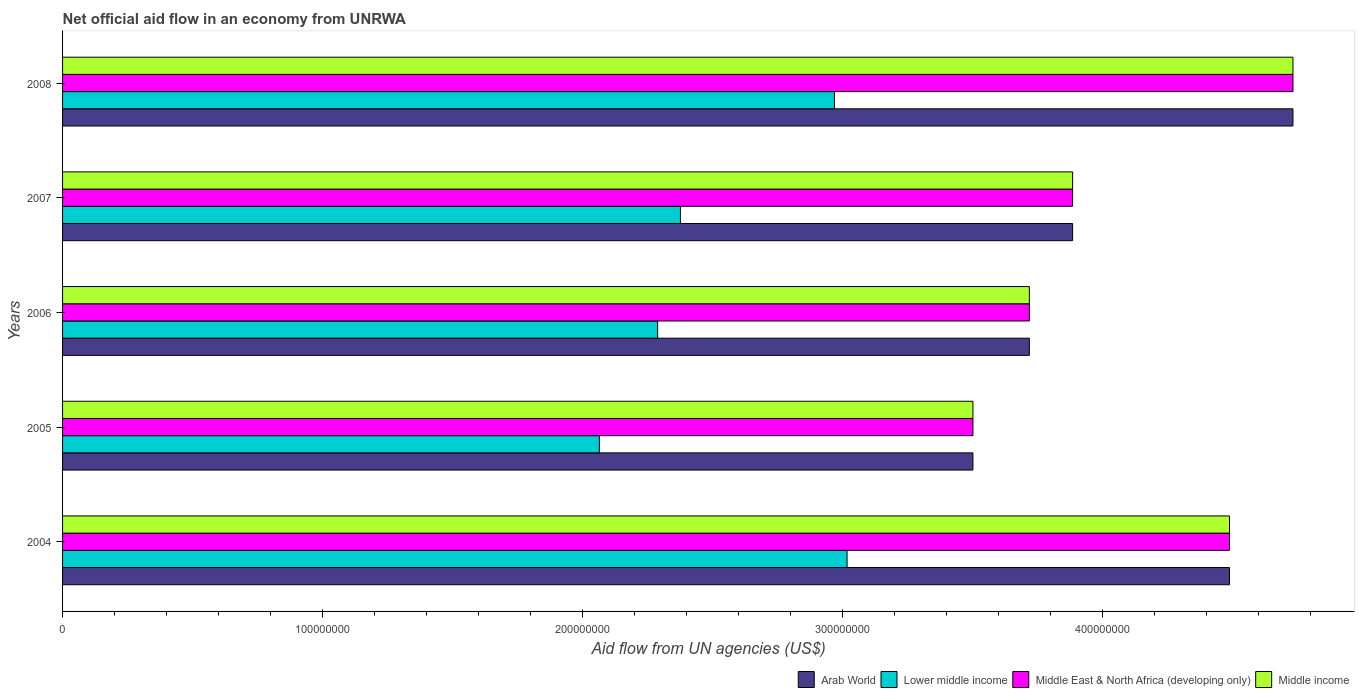How many groups of bars are there?
Your answer should be compact. 5. Are the number of bars on each tick of the Y-axis equal?
Ensure brevity in your answer.  Yes. How many bars are there on the 4th tick from the bottom?
Offer a very short reply. 4. What is the label of the 3rd group of bars from the top?
Give a very brief answer. 2006. What is the net official aid flow in Middle income in 2005?
Keep it short and to the point. 3.50e+08. Across all years, what is the maximum net official aid flow in Arab World?
Offer a terse response. 4.73e+08. Across all years, what is the minimum net official aid flow in Lower middle income?
Keep it short and to the point. 2.06e+08. In which year was the net official aid flow in Lower middle income maximum?
Ensure brevity in your answer.  2004. What is the total net official aid flow in Middle East & North Africa (developing only) in the graph?
Your response must be concise. 2.03e+09. What is the difference between the net official aid flow in Arab World in 2005 and that in 2006?
Keep it short and to the point. -2.17e+07. What is the difference between the net official aid flow in Arab World in 2008 and the net official aid flow in Middle East & North Africa (developing only) in 2007?
Your answer should be very brief. 8.48e+07. What is the average net official aid flow in Middle East & North Africa (developing only) per year?
Keep it short and to the point. 4.06e+08. In the year 2006, what is the difference between the net official aid flow in Middle income and net official aid flow in Lower middle income?
Your answer should be very brief. 1.43e+08. What is the ratio of the net official aid flow in Lower middle income in 2005 to that in 2008?
Keep it short and to the point. 0.7. Is the net official aid flow in Middle income in 2004 less than that in 2007?
Your response must be concise. No. Is the difference between the net official aid flow in Middle income in 2004 and 2006 greater than the difference between the net official aid flow in Lower middle income in 2004 and 2006?
Make the answer very short. Yes. What is the difference between the highest and the second highest net official aid flow in Middle income?
Provide a succinct answer. 2.44e+07. What is the difference between the highest and the lowest net official aid flow in Middle East & North Africa (developing only)?
Make the answer very short. 1.23e+08. In how many years, is the net official aid flow in Lower middle income greater than the average net official aid flow in Lower middle income taken over all years?
Ensure brevity in your answer.  2. Is it the case that in every year, the sum of the net official aid flow in Lower middle income and net official aid flow in Arab World is greater than the sum of net official aid flow in Middle East & North Africa (developing only) and net official aid flow in Middle income?
Provide a short and direct response. Yes. What does the 1st bar from the bottom in 2007 represents?
Your answer should be very brief. Arab World. Is it the case that in every year, the sum of the net official aid flow in Arab World and net official aid flow in Middle income is greater than the net official aid flow in Lower middle income?
Offer a very short reply. Yes. How many bars are there?
Your answer should be compact. 20. Are all the bars in the graph horizontal?
Your response must be concise. Yes. How many years are there in the graph?
Provide a succinct answer. 5. What is the difference between two consecutive major ticks on the X-axis?
Your answer should be very brief. 1.00e+08. Does the graph contain grids?
Offer a terse response. No. Where does the legend appear in the graph?
Your answer should be very brief. Bottom right. How are the legend labels stacked?
Your answer should be compact. Horizontal. What is the title of the graph?
Ensure brevity in your answer.  Net official aid flow in an economy from UNRWA. Does "Rwanda" appear as one of the legend labels in the graph?
Ensure brevity in your answer.  No. What is the label or title of the X-axis?
Your response must be concise. Aid flow from UN agencies (US$). What is the Aid flow from UN agencies (US$) in Arab World in 2004?
Provide a short and direct response. 4.49e+08. What is the Aid flow from UN agencies (US$) of Lower middle income in 2004?
Offer a very short reply. 3.02e+08. What is the Aid flow from UN agencies (US$) of Middle East & North Africa (developing only) in 2004?
Give a very brief answer. 4.49e+08. What is the Aid flow from UN agencies (US$) in Middle income in 2004?
Provide a short and direct response. 4.49e+08. What is the Aid flow from UN agencies (US$) of Arab World in 2005?
Keep it short and to the point. 3.50e+08. What is the Aid flow from UN agencies (US$) of Lower middle income in 2005?
Your answer should be very brief. 2.06e+08. What is the Aid flow from UN agencies (US$) in Middle East & North Africa (developing only) in 2005?
Provide a short and direct response. 3.50e+08. What is the Aid flow from UN agencies (US$) in Middle income in 2005?
Provide a succinct answer. 3.50e+08. What is the Aid flow from UN agencies (US$) of Arab World in 2006?
Your answer should be very brief. 3.72e+08. What is the Aid flow from UN agencies (US$) of Lower middle income in 2006?
Keep it short and to the point. 2.29e+08. What is the Aid flow from UN agencies (US$) in Middle East & North Africa (developing only) in 2006?
Your answer should be compact. 3.72e+08. What is the Aid flow from UN agencies (US$) in Middle income in 2006?
Keep it short and to the point. 3.72e+08. What is the Aid flow from UN agencies (US$) of Arab World in 2007?
Provide a short and direct response. 3.88e+08. What is the Aid flow from UN agencies (US$) in Lower middle income in 2007?
Offer a very short reply. 2.38e+08. What is the Aid flow from UN agencies (US$) in Middle East & North Africa (developing only) in 2007?
Your answer should be compact. 3.88e+08. What is the Aid flow from UN agencies (US$) in Middle income in 2007?
Give a very brief answer. 3.88e+08. What is the Aid flow from UN agencies (US$) of Arab World in 2008?
Make the answer very short. 4.73e+08. What is the Aid flow from UN agencies (US$) of Lower middle income in 2008?
Your answer should be very brief. 2.97e+08. What is the Aid flow from UN agencies (US$) in Middle East & North Africa (developing only) in 2008?
Keep it short and to the point. 4.73e+08. What is the Aid flow from UN agencies (US$) of Middle income in 2008?
Your answer should be very brief. 4.73e+08. Across all years, what is the maximum Aid flow from UN agencies (US$) of Arab World?
Your answer should be compact. 4.73e+08. Across all years, what is the maximum Aid flow from UN agencies (US$) of Lower middle income?
Make the answer very short. 3.02e+08. Across all years, what is the maximum Aid flow from UN agencies (US$) in Middle East & North Africa (developing only)?
Your answer should be very brief. 4.73e+08. Across all years, what is the maximum Aid flow from UN agencies (US$) in Middle income?
Your response must be concise. 4.73e+08. Across all years, what is the minimum Aid flow from UN agencies (US$) of Arab World?
Provide a succinct answer. 3.50e+08. Across all years, what is the minimum Aid flow from UN agencies (US$) in Lower middle income?
Offer a very short reply. 2.06e+08. Across all years, what is the minimum Aid flow from UN agencies (US$) in Middle East & North Africa (developing only)?
Offer a very short reply. 3.50e+08. Across all years, what is the minimum Aid flow from UN agencies (US$) of Middle income?
Your answer should be compact. 3.50e+08. What is the total Aid flow from UN agencies (US$) in Arab World in the graph?
Provide a succinct answer. 2.03e+09. What is the total Aid flow from UN agencies (US$) of Lower middle income in the graph?
Provide a succinct answer. 1.27e+09. What is the total Aid flow from UN agencies (US$) of Middle East & North Africa (developing only) in the graph?
Your answer should be compact. 2.03e+09. What is the total Aid flow from UN agencies (US$) in Middle income in the graph?
Ensure brevity in your answer.  2.03e+09. What is the difference between the Aid flow from UN agencies (US$) of Arab World in 2004 and that in 2005?
Provide a short and direct response. 9.87e+07. What is the difference between the Aid flow from UN agencies (US$) of Lower middle income in 2004 and that in 2005?
Ensure brevity in your answer.  9.53e+07. What is the difference between the Aid flow from UN agencies (US$) in Middle East & North Africa (developing only) in 2004 and that in 2005?
Give a very brief answer. 9.87e+07. What is the difference between the Aid flow from UN agencies (US$) of Middle income in 2004 and that in 2005?
Provide a succinct answer. 9.87e+07. What is the difference between the Aid flow from UN agencies (US$) of Arab World in 2004 and that in 2006?
Ensure brevity in your answer.  7.70e+07. What is the difference between the Aid flow from UN agencies (US$) in Lower middle income in 2004 and that in 2006?
Offer a very short reply. 7.29e+07. What is the difference between the Aid flow from UN agencies (US$) in Middle East & North Africa (developing only) in 2004 and that in 2006?
Offer a very short reply. 7.70e+07. What is the difference between the Aid flow from UN agencies (US$) of Middle income in 2004 and that in 2006?
Keep it short and to the point. 7.70e+07. What is the difference between the Aid flow from UN agencies (US$) of Arab World in 2004 and that in 2007?
Give a very brief answer. 6.03e+07. What is the difference between the Aid flow from UN agencies (US$) of Lower middle income in 2004 and that in 2007?
Give a very brief answer. 6.41e+07. What is the difference between the Aid flow from UN agencies (US$) in Middle East & North Africa (developing only) in 2004 and that in 2007?
Your answer should be very brief. 6.03e+07. What is the difference between the Aid flow from UN agencies (US$) in Middle income in 2004 and that in 2007?
Give a very brief answer. 6.03e+07. What is the difference between the Aid flow from UN agencies (US$) in Arab World in 2004 and that in 2008?
Your answer should be very brief. -2.44e+07. What is the difference between the Aid flow from UN agencies (US$) of Lower middle income in 2004 and that in 2008?
Your answer should be compact. 4.86e+06. What is the difference between the Aid flow from UN agencies (US$) in Middle East & North Africa (developing only) in 2004 and that in 2008?
Your response must be concise. -2.44e+07. What is the difference between the Aid flow from UN agencies (US$) in Middle income in 2004 and that in 2008?
Keep it short and to the point. -2.44e+07. What is the difference between the Aid flow from UN agencies (US$) in Arab World in 2005 and that in 2006?
Keep it short and to the point. -2.17e+07. What is the difference between the Aid flow from UN agencies (US$) in Lower middle income in 2005 and that in 2006?
Your answer should be very brief. -2.24e+07. What is the difference between the Aid flow from UN agencies (US$) of Middle East & North Africa (developing only) in 2005 and that in 2006?
Your response must be concise. -2.17e+07. What is the difference between the Aid flow from UN agencies (US$) in Middle income in 2005 and that in 2006?
Your answer should be compact. -2.17e+07. What is the difference between the Aid flow from UN agencies (US$) in Arab World in 2005 and that in 2007?
Your answer should be very brief. -3.83e+07. What is the difference between the Aid flow from UN agencies (US$) of Lower middle income in 2005 and that in 2007?
Provide a succinct answer. -3.12e+07. What is the difference between the Aid flow from UN agencies (US$) of Middle East & North Africa (developing only) in 2005 and that in 2007?
Ensure brevity in your answer.  -3.83e+07. What is the difference between the Aid flow from UN agencies (US$) of Middle income in 2005 and that in 2007?
Offer a very short reply. -3.83e+07. What is the difference between the Aid flow from UN agencies (US$) in Arab World in 2005 and that in 2008?
Make the answer very short. -1.23e+08. What is the difference between the Aid flow from UN agencies (US$) in Lower middle income in 2005 and that in 2008?
Your response must be concise. -9.04e+07. What is the difference between the Aid flow from UN agencies (US$) of Middle East & North Africa (developing only) in 2005 and that in 2008?
Your answer should be very brief. -1.23e+08. What is the difference between the Aid flow from UN agencies (US$) of Middle income in 2005 and that in 2008?
Your answer should be compact. -1.23e+08. What is the difference between the Aid flow from UN agencies (US$) of Arab World in 2006 and that in 2007?
Offer a terse response. -1.66e+07. What is the difference between the Aid flow from UN agencies (US$) in Lower middle income in 2006 and that in 2007?
Give a very brief answer. -8.77e+06. What is the difference between the Aid flow from UN agencies (US$) of Middle East & North Africa (developing only) in 2006 and that in 2007?
Keep it short and to the point. -1.66e+07. What is the difference between the Aid flow from UN agencies (US$) of Middle income in 2006 and that in 2007?
Keep it short and to the point. -1.66e+07. What is the difference between the Aid flow from UN agencies (US$) in Arab World in 2006 and that in 2008?
Provide a short and direct response. -1.01e+08. What is the difference between the Aid flow from UN agencies (US$) in Lower middle income in 2006 and that in 2008?
Your response must be concise. -6.80e+07. What is the difference between the Aid flow from UN agencies (US$) in Middle East & North Africa (developing only) in 2006 and that in 2008?
Your answer should be compact. -1.01e+08. What is the difference between the Aid flow from UN agencies (US$) in Middle income in 2006 and that in 2008?
Ensure brevity in your answer.  -1.01e+08. What is the difference between the Aid flow from UN agencies (US$) in Arab World in 2007 and that in 2008?
Ensure brevity in your answer.  -8.48e+07. What is the difference between the Aid flow from UN agencies (US$) in Lower middle income in 2007 and that in 2008?
Give a very brief answer. -5.92e+07. What is the difference between the Aid flow from UN agencies (US$) of Middle East & North Africa (developing only) in 2007 and that in 2008?
Your answer should be compact. -8.48e+07. What is the difference between the Aid flow from UN agencies (US$) in Middle income in 2007 and that in 2008?
Give a very brief answer. -8.48e+07. What is the difference between the Aid flow from UN agencies (US$) in Arab World in 2004 and the Aid flow from UN agencies (US$) in Lower middle income in 2005?
Your answer should be very brief. 2.42e+08. What is the difference between the Aid flow from UN agencies (US$) in Arab World in 2004 and the Aid flow from UN agencies (US$) in Middle East & North Africa (developing only) in 2005?
Make the answer very short. 9.87e+07. What is the difference between the Aid flow from UN agencies (US$) of Arab World in 2004 and the Aid flow from UN agencies (US$) of Middle income in 2005?
Your response must be concise. 9.87e+07. What is the difference between the Aid flow from UN agencies (US$) in Lower middle income in 2004 and the Aid flow from UN agencies (US$) in Middle East & North Africa (developing only) in 2005?
Make the answer very short. -4.84e+07. What is the difference between the Aid flow from UN agencies (US$) in Lower middle income in 2004 and the Aid flow from UN agencies (US$) in Middle income in 2005?
Your response must be concise. -4.84e+07. What is the difference between the Aid flow from UN agencies (US$) in Middle East & North Africa (developing only) in 2004 and the Aid flow from UN agencies (US$) in Middle income in 2005?
Your answer should be very brief. 9.87e+07. What is the difference between the Aid flow from UN agencies (US$) in Arab World in 2004 and the Aid flow from UN agencies (US$) in Lower middle income in 2006?
Provide a succinct answer. 2.20e+08. What is the difference between the Aid flow from UN agencies (US$) of Arab World in 2004 and the Aid flow from UN agencies (US$) of Middle East & North Africa (developing only) in 2006?
Your response must be concise. 7.70e+07. What is the difference between the Aid flow from UN agencies (US$) in Arab World in 2004 and the Aid flow from UN agencies (US$) in Middle income in 2006?
Offer a terse response. 7.70e+07. What is the difference between the Aid flow from UN agencies (US$) in Lower middle income in 2004 and the Aid flow from UN agencies (US$) in Middle East & North Africa (developing only) in 2006?
Make the answer very short. -7.01e+07. What is the difference between the Aid flow from UN agencies (US$) in Lower middle income in 2004 and the Aid flow from UN agencies (US$) in Middle income in 2006?
Keep it short and to the point. -7.01e+07. What is the difference between the Aid flow from UN agencies (US$) in Middle East & North Africa (developing only) in 2004 and the Aid flow from UN agencies (US$) in Middle income in 2006?
Provide a succinct answer. 7.70e+07. What is the difference between the Aid flow from UN agencies (US$) of Arab World in 2004 and the Aid flow from UN agencies (US$) of Lower middle income in 2007?
Offer a terse response. 2.11e+08. What is the difference between the Aid flow from UN agencies (US$) in Arab World in 2004 and the Aid flow from UN agencies (US$) in Middle East & North Africa (developing only) in 2007?
Give a very brief answer. 6.03e+07. What is the difference between the Aid flow from UN agencies (US$) in Arab World in 2004 and the Aid flow from UN agencies (US$) in Middle income in 2007?
Provide a succinct answer. 6.03e+07. What is the difference between the Aid flow from UN agencies (US$) in Lower middle income in 2004 and the Aid flow from UN agencies (US$) in Middle East & North Africa (developing only) in 2007?
Your answer should be very brief. -8.67e+07. What is the difference between the Aid flow from UN agencies (US$) in Lower middle income in 2004 and the Aid flow from UN agencies (US$) in Middle income in 2007?
Your response must be concise. -8.67e+07. What is the difference between the Aid flow from UN agencies (US$) of Middle East & North Africa (developing only) in 2004 and the Aid flow from UN agencies (US$) of Middle income in 2007?
Offer a very short reply. 6.03e+07. What is the difference between the Aid flow from UN agencies (US$) in Arab World in 2004 and the Aid flow from UN agencies (US$) in Lower middle income in 2008?
Keep it short and to the point. 1.52e+08. What is the difference between the Aid flow from UN agencies (US$) of Arab World in 2004 and the Aid flow from UN agencies (US$) of Middle East & North Africa (developing only) in 2008?
Offer a terse response. -2.44e+07. What is the difference between the Aid flow from UN agencies (US$) of Arab World in 2004 and the Aid flow from UN agencies (US$) of Middle income in 2008?
Keep it short and to the point. -2.44e+07. What is the difference between the Aid flow from UN agencies (US$) of Lower middle income in 2004 and the Aid flow from UN agencies (US$) of Middle East & North Africa (developing only) in 2008?
Keep it short and to the point. -1.71e+08. What is the difference between the Aid flow from UN agencies (US$) of Lower middle income in 2004 and the Aid flow from UN agencies (US$) of Middle income in 2008?
Make the answer very short. -1.71e+08. What is the difference between the Aid flow from UN agencies (US$) in Middle East & North Africa (developing only) in 2004 and the Aid flow from UN agencies (US$) in Middle income in 2008?
Your response must be concise. -2.44e+07. What is the difference between the Aid flow from UN agencies (US$) in Arab World in 2005 and the Aid flow from UN agencies (US$) in Lower middle income in 2006?
Provide a succinct answer. 1.21e+08. What is the difference between the Aid flow from UN agencies (US$) of Arab World in 2005 and the Aid flow from UN agencies (US$) of Middle East & North Africa (developing only) in 2006?
Give a very brief answer. -2.17e+07. What is the difference between the Aid flow from UN agencies (US$) in Arab World in 2005 and the Aid flow from UN agencies (US$) in Middle income in 2006?
Your answer should be very brief. -2.17e+07. What is the difference between the Aid flow from UN agencies (US$) of Lower middle income in 2005 and the Aid flow from UN agencies (US$) of Middle East & North Africa (developing only) in 2006?
Your response must be concise. -1.65e+08. What is the difference between the Aid flow from UN agencies (US$) of Lower middle income in 2005 and the Aid flow from UN agencies (US$) of Middle income in 2006?
Make the answer very short. -1.65e+08. What is the difference between the Aid flow from UN agencies (US$) in Middle East & North Africa (developing only) in 2005 and the Aid flow from UN agencies (US$) in Middle income in 2006?
Keep it short and to the point. -2.17e+07. What is the difference between the Aid flow from UN agencies (US$) in Arab World in 2005 and the Aid flow from UN agencies (US$) in Lower middle income in 2007?
Give a very brief answer. 1.12e+08. What is the difference between the Aid flow from UN agencies (US$) of Arab World in 2005 and the Aid flow from UN agencies (US$) of Middle East & North Africa (developing only) in 2007?
Your answer should be very brief. -3.83e+07. What is the difference between the Aid flow from UN agencies (US$) in Arab World in 2005 and the Aid flow from UN agencies (US$) in Middle income in 2007?
Provide a short and direct response. -3.83e+07. What is the difference between the Aid flow from UN agencies (US$) in Lower middle income in 2005 and the Aid flow from UN agencies (US$) in Middle East & North Africa (developing only) in 2007?
Keep it short and to the point. -1.82e+08. What is the difference between the Aid flow from UN agencies (US$) of Lower middle income in 2005 and the Aid flow from UN agencies (US$) of Middle income in 2007?
Your answer should be compact. -1.82e+08. What is the difference between the Aid flow from UN agencies (US$) in Middle East & North Africa (developing only) in 2005 and the Aid flow from UN agencies (US$) in Middle income in 2007?
Ensure brevity in your answer.  -3.83e+07. What is the difference between the Aid flow from UN agencies (US$) of Arab World in 2005 and the Aid flow from UN agencies (US$) of Lower middle income in 2008?
Offer a very short reply. 5.33e+07. What is the difference between the Aid flow from UN agencies (US$) of Arab World in 2005 and the Aid flow from UN agencies (US$) of Middle East & North Africa (developing only) in 2008?
Offer a very short reply. -1.23e+08. What is the difference between the Aid flow from UN agencies (US$) of Arab World in 2005 and the Aid flow from UN agencies (US$) of Middle income in 2008?
Offer a very short reply. -1.23e+08. What is the difference between the Aid flow from UN agencies (US$) of Lower middle income in 2005 and the Aid flow from UN agencies (US$) of Middle East & North Africa (developing only) in 2008?
Your answer should be compact. -2.67e+08. What is the difference between the Aid flow from UN agencies (US$) in Lower middle income in 2005 and the Aid flow from UN agencies (US$) in Middle income in 2008?
Provide a short and direct response. -2.67e+08. What is the difference between the Aid flow from UN agencies (US$) in Middle East & North Africa (developing only) in 2005 and the Aid flow from UN agencies (US$) in Middle income in 2008?
Your answer should be compact. -1.23e+08. What is the difference between the Aid flow from UN agencies (US$) in Arab World in 2006 and the Aid flow from UN agencies (US$) in Lower middle income in 2007?
Ensure brevity in your answer.  1.34e+08. What is the difference between the Aid flow from UN agencies (US$) of Arab World in 2006 and the Aid flow from UN agencies (US$) of Middle East & North Africa (developing only) in 2007?
Offer a very short reply. -1.66e+07. What is the difference between the Aid flow from UN agencies (US$) of Arab World in 2006 and the Aid flow from UN agencies (US$) of Middle income in 2007?
Your response must be concise. -1.66e+07. What is the difference between the Aid flow from UN agencies (US$) of Lower middle income in 2006 and the Aid flow from UN agencies (US$) of Middle East & North Africa (developing only) in 2007?
Make the answer very short. -1.60e+08. What is the difference between the Aid flow from UN agencies (US$) of Lower middle income in 2006 and the Aid flow from UN agencies (US$) of Middle income in 2007?
Offer a terse response. -1.60e+08. What is the difference between the Aid flow from UN agencies (US$) in Middle East & North Africa (developing only) in 2006 and the Aid flow from UN agencies (US$) in Middle income in 2007?
Provide a short and direct response. -1.66e+07. What is the difference between the Aid flow from UN agencies (US$) of Arab World in 2006 and the Aid flow from UN agencies (US$) of Lower middle income in 2008?
Provide a succinct answer. 7.50e+07. What is the difference between the Aid flow from UN agencies (US$) in Arab World in 2006 and the Aid flow from UN agencies (US$) in Middle East & North Africa (developing only) in 2008?
Provide a short and direct response. -1.01e+08. What is the difference between the Aid flow from UN agencies (US$) in Arab World in 2006 and the Aid flow from UN agencies (US$) in Middle income in 2008?
Offer a terse response. -1.01e+08. What is the difference between the Aid flow from UN agencies (US$) of Lower middle income in 2006 and the Aid flow from UN agencies (US$) of Middle East & North Africa (developing only) in 2008?
Keep it short and to the point. -2.44e+08. What is the difference between the Aid flow from UN agencies (US$) in Lower middle income in 2006 and the Aid flow from UN agencies (US$) in Middle income in 2008?
Ensure brevity in your answer.  -2.44e+08. What is the difference between the Aid flow from UN agencies (US$) in Middle East & North Africa (developing only) in 2006 and the Aid flow from UN agencies (US$) in Middle income in 2008?
Offer a very short reply. -1.01e+08. What is the difference between the Aid flow from UN agencies (US$) in Arab World in 2007 and the Aid flow from UN agencies (US$) in Lower middle income in 2008?
Provide a short and direct response. 9.16e+07. What is the difference between the Aid flow from UN agencies (US$) of Arab World in 2007 and the Aid flow from UN agencies (US$) of Middle East & North Africa (developing only) in 2008?
Offer a terse response. -8.48e+07. What is the difference between the Aid flow from UN agencies (US$) in Arab World in 2007 and the Aid flow from UN agencies (US$) in Middle income in 2008?
Make the answer very short. -8.48e+07. What is the difference between the Aid flow from UN agencies (US$) in Lower middle income in 2007 and the Aid flow from UN agencies (US$) in Middle East & North Africa (developing only) in 2008?
Offer a terse response. -2.36e+08. What is the difference between the Aid flow from UN agencies (US$) in Lower middle income in 2007 and the Aid flow from UN agencies (US$) in Middle income in 2008?
Offer a very short reply. -2.36e+08. What is the difference between the Aid flow from UN agencies (US$) of Middle East & North Africa (developing only) in 2007 and the Aid flow from UN agencies (US$) of Middle income in 2008?
Offer a very short reply. -8.48e+07. What is the average Aid flow from UN agencies (US$) of Arab World per year?
Offer a very short reply. 4.06e+08. What is the average Aid flow from UN agencies (US$) of Lower middle income per year?
Your answer should be very brief. 2.54e+08. What is the average Aid flow from UN agencies (US$) in Middle East & North Africa (developing only) per year?
Offer a very short reply. 4.06e+08. What is the average Aid flow from UN agencies (US$) of Middle income per year?
Keep it short and to the point. 4.06e+08. In the year 2004, what is the difference between the Aid flow from UN agencies (US$) in Arab World and Aid flow from UN agencies (US$) in Lower middle income?
Make the answer very short. 1.47e+08. In the year 2004, what is the difference between the Aid flow from UN agencies (US$) in Arab World and Aid flow from UN agencies (US$) in Middle East & North Africa (developing only)?
Make the answer very short. 0. In the year 2004, what is the difference between the Aid flow from UN agencies (US$) in Lower middle income and Aid flow from UN agencies (US$) in Middle East & North Africa (developing only)?
Offer a very short reply. -1.47e+08. In the year 2004, what is the difference between the Aid flow from UN agencies (US$) in Lower middle income and Aid flow from UN agencies (US$) in Middle income?
Offer a very short reply. -1.47e+08. In the year 2004, what is the difference between the Aid flow from UN agencies (US$) in Middle East & North Africa (developing only) and Aid flow from UN agencies (US$) in Middle income?
Your answer should be compact. 0. In the year 2005, what is the difference between the Aid flow from UN agencies (US$) in Arab World and Aid flow from UN agencies (US$) in Lower middle income?
Provide a short and direct response. 1.44e+08. In the year 2005, what is the difference between the Aid flow from UN agencies (US$) in Arab World and Aid flow from UN agencies (US$) in Middle East & North Africa (developing only)?
Make the answer very short. 0. In the year 2005, what is the difference between the Aid flow from UN agencies (US$) in Arab World and Aid flow from UN agencies (US$) in Middle income?
Your response must be concise. 0. In the year 2005, what is the difference between the Aid flow from UN agencies (US$) in Lower middle income and Aid flow from UN agencies (US$) in Middle East & North Africa (developing only)?
Give a very brief answer. -1.44e+08. In the year 2005, what is the difference between the Aid flow from UN agencies (US$) of Lower middle income and Aid flow from UN agencies (US$) of Middle income?
Offer a very short reply. -1.44e+08. In the year 2005, what is the difference between the Aid flow from UN agencies (US$) of Middle East & North Africa (developing only) and Aid flow from UN agencies (US$) of Middle income?
Offer a very short reply. 0. In the year 2006, what is the difference between the Aid flow from UN agencies (US$) in Arab World and Aid flow from UN agencies (US$) in Lower middle income?
Offer a terse response. 1.43e+08. In the year 2006, what is the difference between the Aid flow from UN agencies (US$) of Lower middle income and Aid flow from UN agencies (US$) of Middle East & North Africa (developing only)?
Make the answer very short. -1.43e+08. In the year 2006, what is the difference between the Aid flow from UN agencies (US$) of Lower middle income and Aid flow from UN agencies (US$) of Middle income?
Make the answer very short. -1.43e+08. In the year 2007, what is the difference between the Aid flow from UN agencies (US$) in Arab World and Aid flow from UN agencies (US$) in Lower middle income?
Offer a terse response. 1.51e+08. In the year 2007, what is the difference between the Aid flow from UN agencies (US$) in Arab World and Aid flow from UN agencies (US$) in Middle East & North Africa (developing only)?
Provide a succinct answer. 0. In the year 2007, what is the difference between the Aid flow from UN agencies (US$) in Lower middle income and Aid flow from UN agencies (US$) in Middle East & North Africa (developing only)?
Your answer should be very brief. -1.51e+08. In the year 2007, what is the difference between the Aid flow from UN agencies (US$) in Lower middle income and Aid flow from UN agencies (US$) in Middle income?
Offer a terse response. -1.51e+08. In the year 2007, what is the difference between the Aid flow from UN agencies (US$) in Middle East & North Africa (developing only) and Aid flow from UN agencies (US$) in Middle income?
Keep it short and to the point. 0. In the year 2008, what is the difference between the Aid flow from UN agencies (US$) in Arab World and Aid flow from UN agencies (US$) in Lower middle income?
Keep it short and to the point. 1.76e+08. In the year 2008, what is the difference between the Aid flow from UN agencies (US$) in Arab World and Aid flow from UN agencies (US$) in Middle income?
Make the answer very short. 0. In the year 2008, what is the difference between the Aid flow from UN agencies (US$) of Lower middle income and Aid flow from UN agencies (US$) of Middle East & North Africa (developing only)?
Your answer should be very brief. -1.76e+08. In the year 2008, what is the difference between the Aid flow from UN agencies (US$) of Lower middle income and Aid flow from UN agencies (US$) of Middle income?
Give a very brief answer. -1.76e+08. What is the ratio of the Aid flow from UN agencies (US$) in Arab World in 2004 to that in 2005?
Your answer should be very brief. 1.28. What is the ratio of the Aid flow from UN agencies (US$) of Lower middle income in 2004 to that in 2005?
Offer a very short reply. 1.46. What is the ratio of the Aid flow from UN agencies (US$) in Middle East & North Africa (developing only) in 2004 to that in 2005?
Provide a short and direct response. 1.28. What is the ratio of the Aid flow from UN agencies (US$) of Middle income in 2004 to that in 2005?
Your answer should be very brief. 1.28. What is the ratio of the Aid flow from UN agencies (US$) of Arab World in 2004 to that in 2006?
Provide a short and direct response. 1.21. What is the ratio of the Aid flow from UN agencies (US$) of Lower middle income in 2004 to that in 2006?
Ensure brevity in your answer.  1.32. What is the ratio of the Aid flow from UN agencies (US$) of Middle East & North Africa (developing only) in 2004 to that in 2006?
Provide a short and direct response. 1.21. What is the ratio of the Aid flow from UN agencies (US$) in Middle income in 2004 to that in 2006?
Ensure brevity in your answer.  1.21. What is the ratio of the Aid flow from UN agencies (US$) in Arab World in 2004 to that in 2007?
Make the answer very short. 1.16. What is the ratio of the Aid flow from UN agencies (US$) in Lower middle income in 2004 to that in 2007?
Your answer should be compact. 1.27. What is the ratio of the Aid flow from UN agencies (US$) in Middle East & North Africa (developing only) in 2004 to that in 2007?
Give a very brief answer. 1.16. What is the ratio of the Aid flow from UN agencies (US$) in Middle income in 2004 to that in 2007?
Your response must be concise. 1.16. What is the ratio of the Aid flow from UN agencies (US$) of Arab World in 2004 to that in 2008?
Your answer should be compact. 0.95. What is the ratio of the Aid flow from UN agencies (US$) of Lower middle income in 2004 to that in 2008?
Provide a succinct answer. 1.02. What is the ratio of the Aid flow from UN agencies (US$) in Middle East & North Africa (developing only) in 2004 to that in 2008?
Offer a very short reply. 0.95. What is the ratio of the Aid flow from UN agencies (US$) of Middle income in 2004 to that in 2008?
Keep it short and to the point. 0.95. What is the ratio of the Aid flow from UN agencies (US$) of Arab World in 2005 to that in 2006?
Your answer should be compact. 0.94. What is the ratio of the Aid flow from UN agencies (US$) in Lower middle income in 2005 to that in 2006?
Ensure brevity in your answer.  0.9. What is the ratio of the Aid flow from UN agencies (US$) of Middle East & North Africa (developing only) in 2005 to that in 2006?
Keep it short and to the point. 0.94. What is the ratio of the Aid flow from UN agencies (US$) in Middle income in 2005 to that in 2006?
Provide a short and direct response. 0.94. What is the ratio of the Aid flow from UN agencies (US$) in Arab World in 2005 to that in 2007?
Ensure brevity in your answer.  0.9. What is the ratio of the Aid flow from UN agencies (US$) in Lower middle income in 2005 to that in 2007?
Keep it short and to the point. 0.87. What is the ratio of the Aid flow from UN agencies (US$) of Middle East & North Africa (developing only) in 2005 to that in 2007?
Make the answer very short. 0.9. What is the ratio of the Aid flow from UN agencies (US$) in Middle income in 2005 to that in 2007?
Provide a succinct answer. 0.9. What is the ratio of the Aid flow from UN agencies (US$) in Arab World in 2005 to that in 2008?
Offer a very short reply. 0.74. What is the ratio of the Aid flow from UN agencies (US$) in Lower middle income in 2005 to that in 2008?
Offer a terse response. 0.7. What is the ratio of the Aid flow from UN agencies (US$) of Middle East & North Africa (developing only) in 2005 to that in 2008?
Provide a short and direct response. 0.74. What is the ratio of the Aid flow from UN agencies (US$) in Middle income in 2005 to that in 2008?
Make the answer very short. 0.74. What is the ratio of the Aid flow from UN agencies (US$) of Arab World in 2006 to that in 2007?
Your response must be concise. 0.96. What is the ratio of the Aid flow from UN agencies (US$) of Lower middle income in 2006 to that in 2007?
Give a very brief answer. 0.96. What is the ratio of the Aid flow from UN agencies (US$) of Middle East & North Africa (developing only) in 2006 to that in 2007?
Make the answer very short. 0.96. What is the ratio of the Aid flow from UN agencies (US$) in Middle income in 2006 to that in 2007?
Your response must be concise. 0.96. What is the ratio of the Aid flow from UN agencies (US$) of Arab World in 2006 to that in 2008?
Provide a succinct answer. 0.79. What is the ratio of the Aid flow from UN agencies (US$) in Lower middle income in 2006 to that in 2008?
Provide a short and direct response. 0.77. What is the ratio of the Aid flow from UN agencies (US$) of Middle East & North Africa (developing only) in 2006 to that in 2008?
Your answer should be very brief. 0.79. What is the ratio of the Aid flow from UN agencies (US$) of Middle income in 2006 to that in 2008?
Offer a terse response. 0.79. What is the ratio of the Aid flow from UN agencies (US$) of Arab World in 2007 to that in 2008?
Your response must be concise. 0.82. What is the ratio of the Aid flow from UN agencies (US$) of Lower middle income in 2007 to that in 2008?
Your answer should be very brief. 0.8. What is the ratio of the Aid flow from UN agencies (US$) of Middle East & North Africa (developing only) in 2007 to that in 2008?
Offer a terse response. 0.82. What is the ratio of the Aid flow from UN agencies (US$) of Middle income in 2007 to that in 2008?
Provide a succinct answer. 0.82. What is the difference between the highest and the second highest Aid flow from UN agencies (US$) of Arab World?
Provide a short and direct response. 2.44e+07. What is the difference between the highest and the second highest Aid flow from UN agencies (US$) in Lower middle income?
Provide a short and direct response. 4.86e+06. What is the difference between the highest and the second highest Aid flow from UN agencies (US$) in Middle East & North Africa (developing only)?
Provide a succinct answer. 2.44e+07. What is the difference between the highest and the second highest Aid flow from UN agencies (US$) of Middle income?
Your response must be concise. 2.44e+07. What is the difference between the highest and the lowest Aid flow from UN agencies (US$) in Arab World?
Your answer should be very brief. 1.23e+08. What is the difference between the highest and the lowest Aid flow from UN agencies (US$) in Lower middle income?
Your response must be concise. 9.53e+07. What is the difference between the highest and the lowest Aid flow from UN agencies (US$) of Middle East & North Africa (developing only)?
Provide a short and direct response. 1.23e+08. What is the difference between the highest and the lowest Aid flow from UN agencies (US$) of Middle income?
Provide a succinct answer. 1.23e+08. 